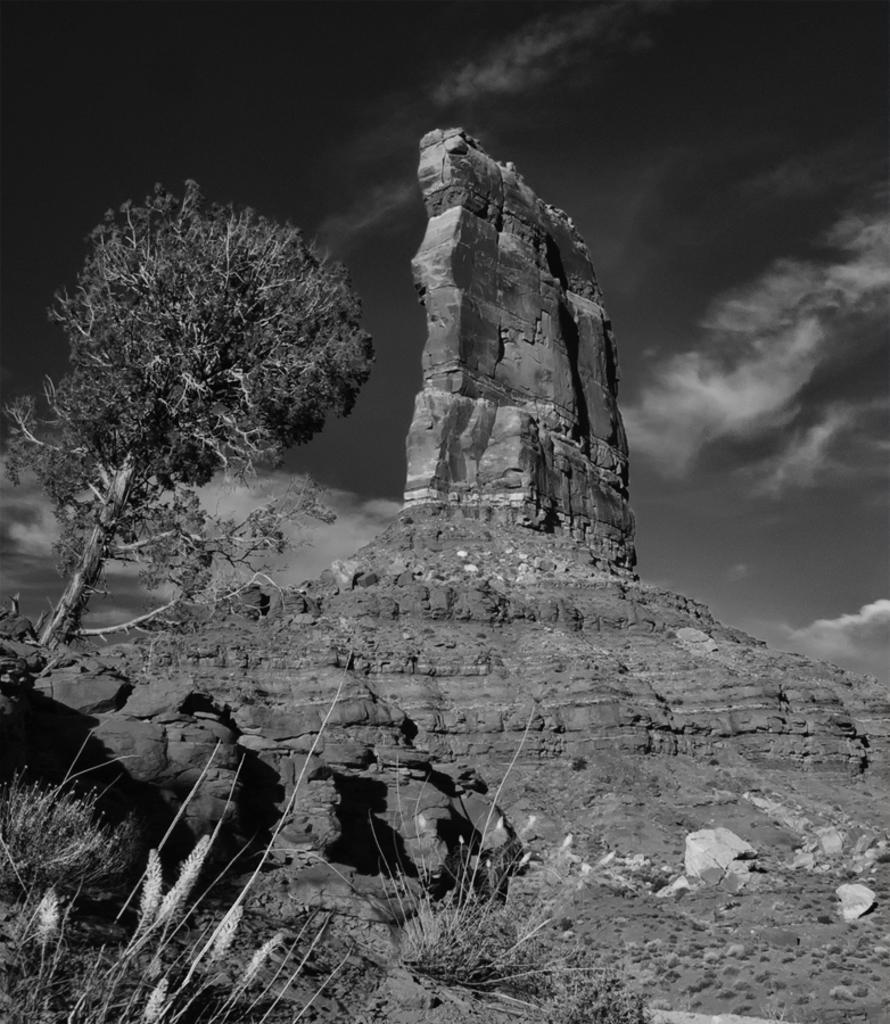In one or two sentences, can you explain what this image depicts? This is a black and white image in which we can see the hill, stones, plants, a tree and the sky which looks cloudy. 